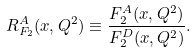Convert formula to latex. <formula><loc_0><loc_0><loc_500><loc_500>R _ { F _ { 2 } } ^ { A } ( x , Q ^ { 2 } ) \equiv \frac { F _ { 2 } ^ { A } ( x , Q ^ { 2 } ) } { F _ { 2 } ^ { D } ( x , Q ^ { 2 } ) } .</formula> 